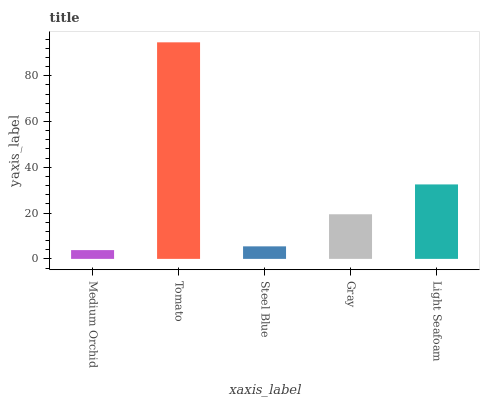Is Medium Orchid the minimum?
Answer yes or no. Yes. Is Tomato the maximum?
Answer yes or no. Yes. Is Steel Blue the minimum?
Answer yes or no. No. Is Steel Blue the maximum?
Answer yes or no. No. Is Tomato greater than Steel Blue?
Answer yes or no. Yes. Is Steel Blue less than Tomato?
Answer yes or no. Yes. Is Steel Blue greater than Tomato?
Answer yes or no. No. Is Tomato less than Steel Blue?
Answer yes or no. No. Is Gray the high median?
Answer yes or no. Yes. Is Gray the low median?
Answer yes or no. Yes. Is Light Seafoam the high median?
Answer yes or no. No. Is Tomato the low median?
Answer yes or no. No. 